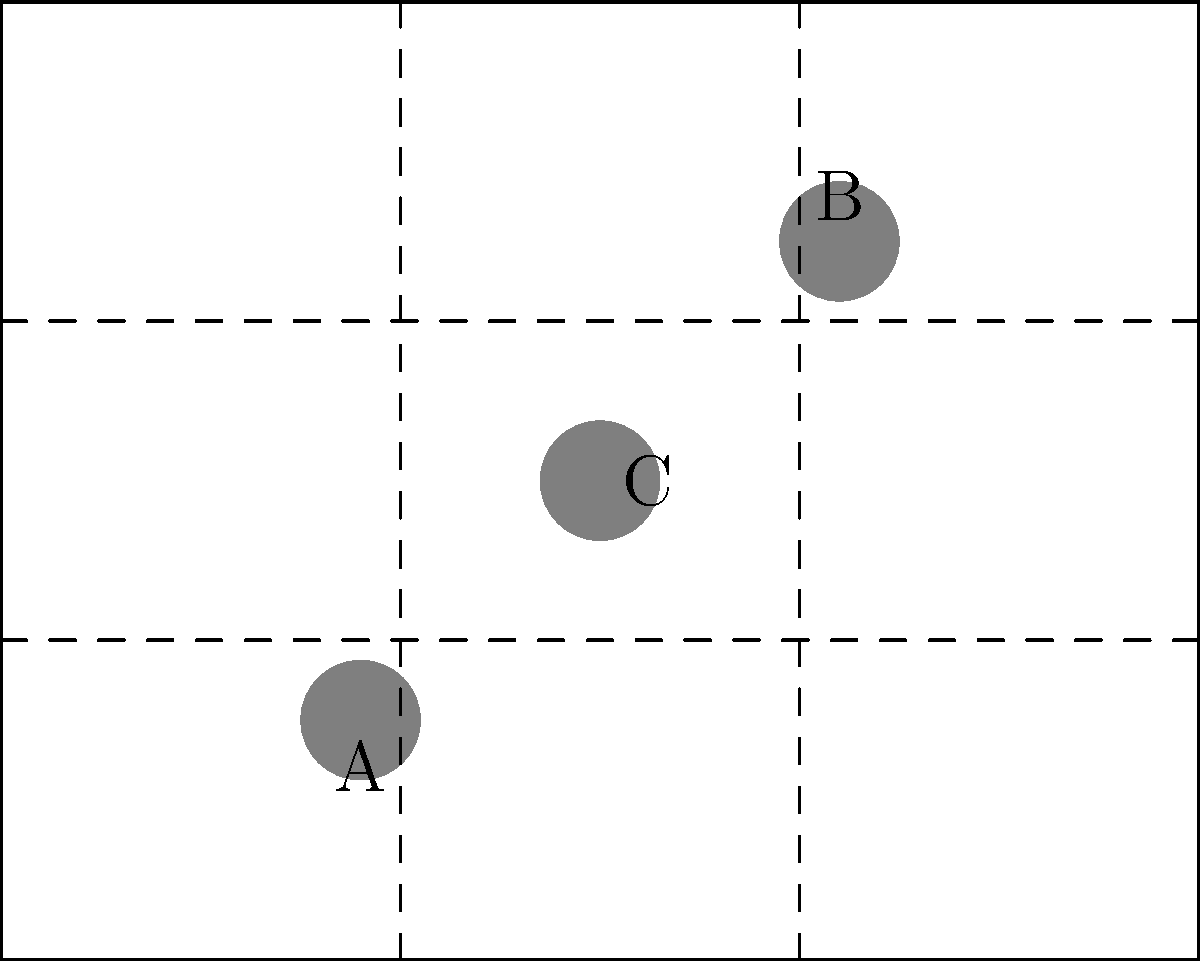In the given frame, three subjects (A, B, and C) are positioned. Which arrangement would best adhere to the rule of thirds for a balanced composition? To determine the best arrangement according to the rule of thirds, we need to follow these steps:

1. Understand the rule of thirds: This compositional guideline divides the frame into a 3x3 grid, creating four intersection points.

2. Analyze the current positions:
   - Subject A is near the bottom-left intersection point
   - Subject B is near the top-right intersection point
   - Subject C is near the center of the frame

3. Evaluate the balance:
   - Subjects A and B are already placed near rule of thirds intersection points, which is ideal.
   - Subject C is in the center, which is less dynamic according to the rule of thirds.

4. Consider improvement:
   - Moving subject C to one of the remaining intersection points (top-left or bottom-right) would create a more balanced composition according to the rule of thirds.

5. Conclusion:
   The best arrangement would be to keep subjects A and B in their current positions and move subject C to either the top-left or bottom-right intersection point.
Answer: Keep A and B, move C to top-left or bottom-right intersection 